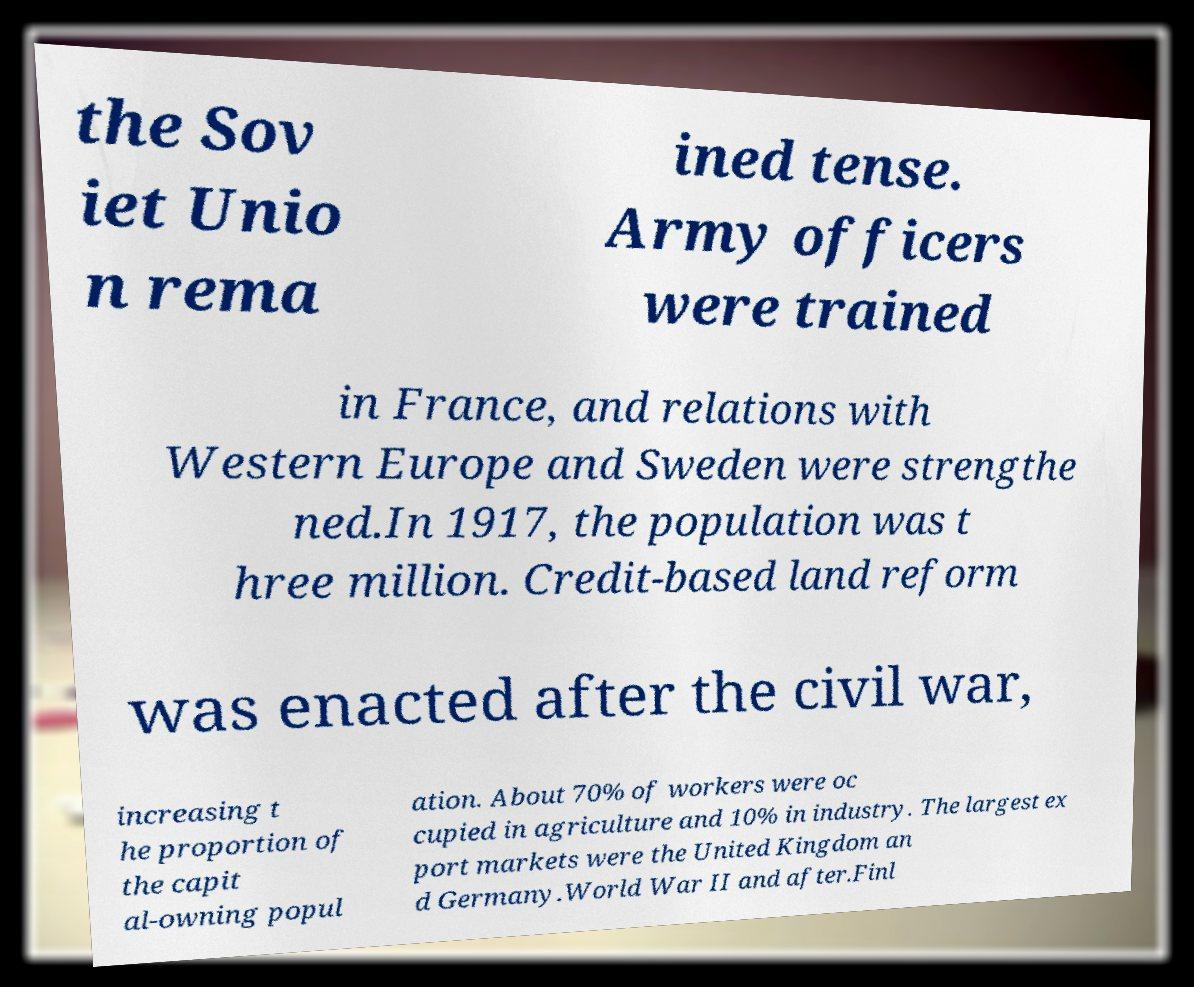Please read and relay the text visible in this image. What does it say? the Sov iet Unio n rema ined tense. Army officers were trained in France, and relations with Western Europe and Sweden were strengthe ned.In 1917, the population was t hree million. Credit-based land reform was enacted after the civil war, increasing t he proportion of the capit al-owning popul ation. About 70% of workers were oc cupied in agriculture and 10% in industry. The largest ex port markets were the United Kingdom an d Germany.World War II and after.Finl 